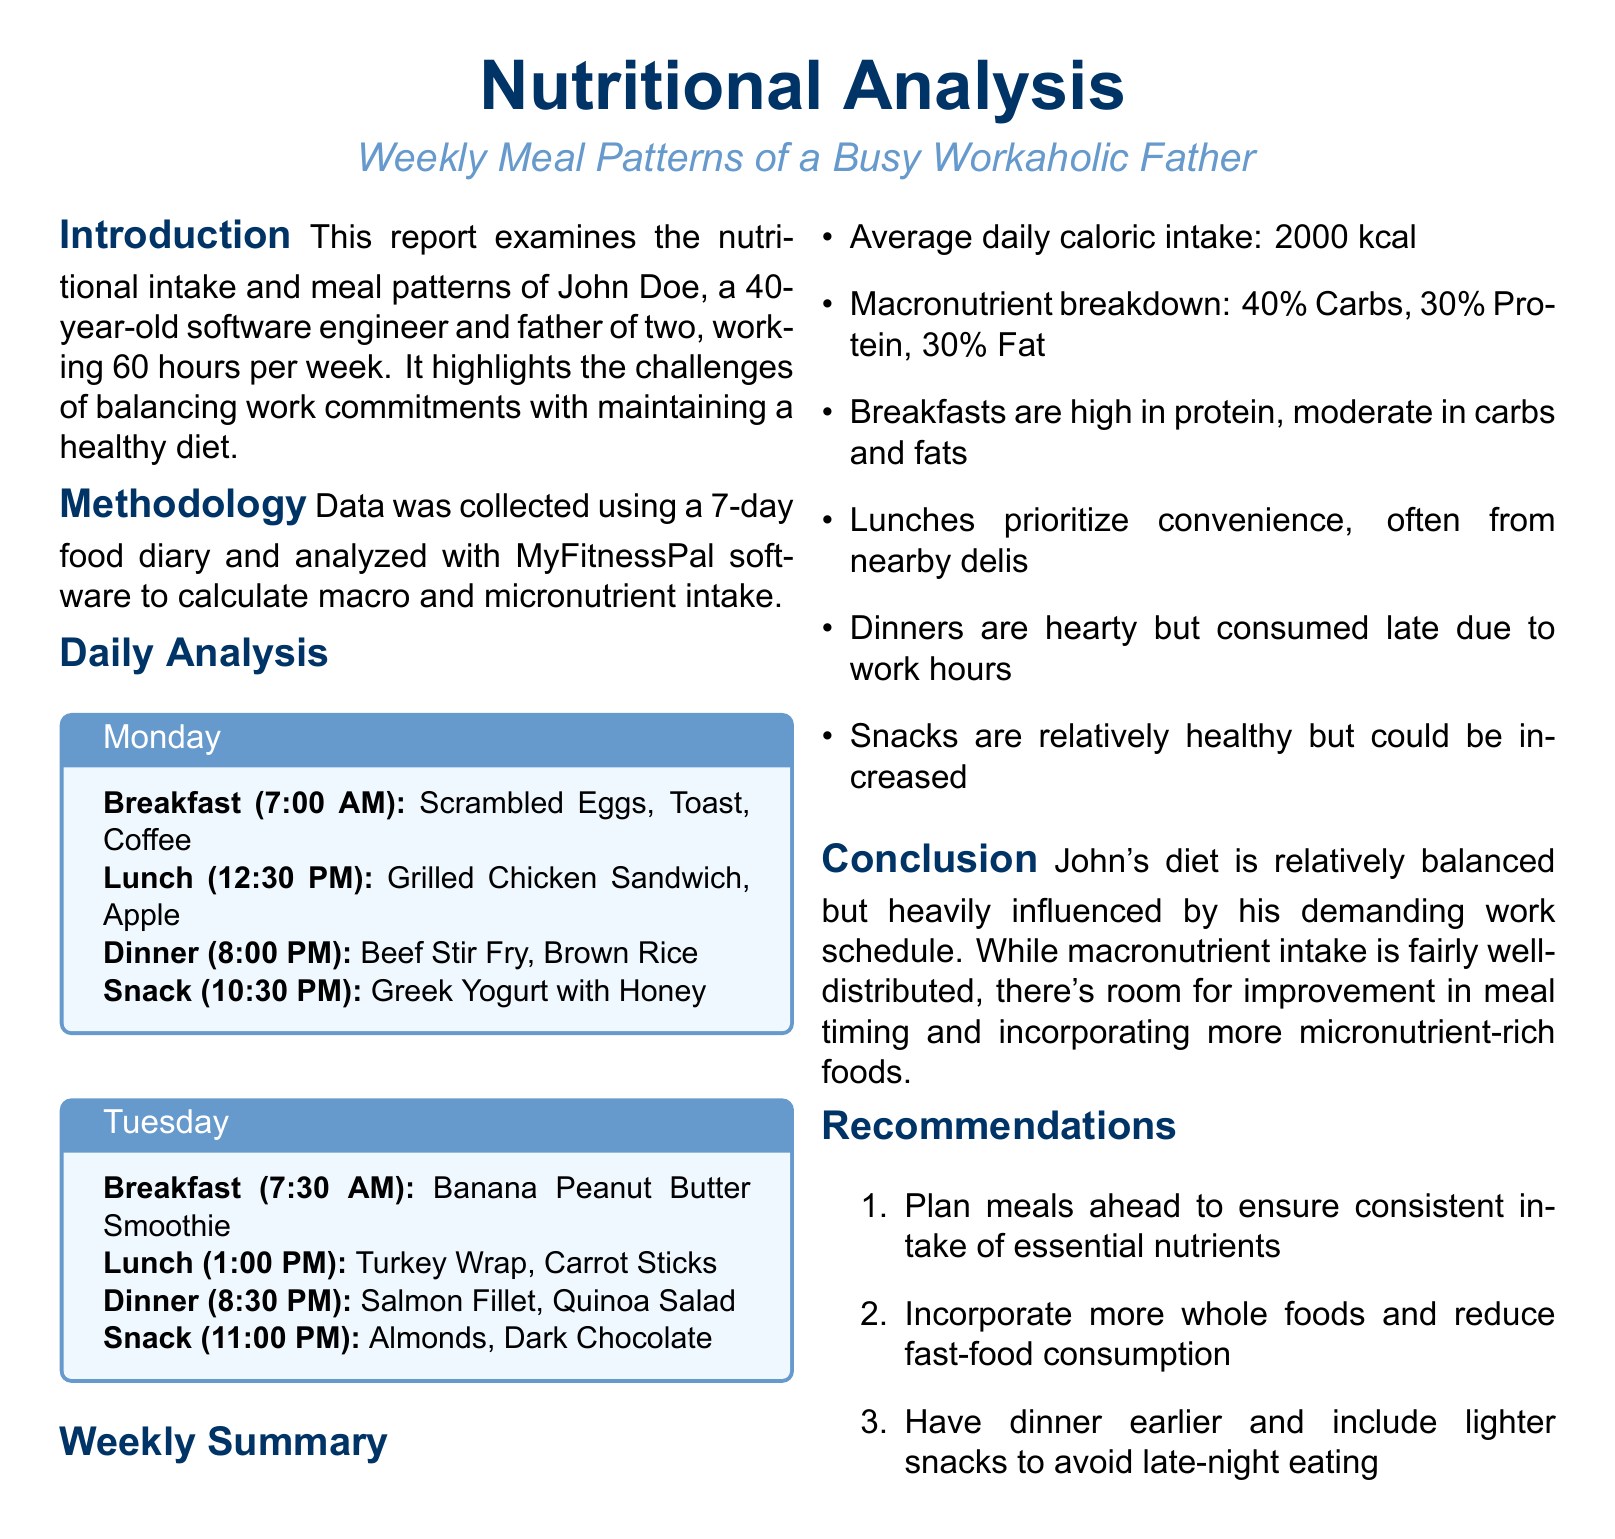What is the average daily caloric intake? The average daily caloric intake is calculated based on the meals consumed over the week, which is 2000 kcal.
Answer: 2000 kcal What is the macronutrient breakdown? The macronutrient breakdown shows the percentage distribution of different nutrients in the diet, which is 40% Carbs, 30% Protein, 30% Fat.
Answer: 40% Carbs, 30% Protein, 30% Fat What time is breakfast typically eaten? Breakfast time is stated for each day, with Monday at 7:00 AM and Tuesday at 7:30 AM indicating it is consumed in the morning.
Answer: 7:00 AM What kind of meals are prioritized for lunch? Lunch meals tend to focus on convenience due to the busy schedule, often sourced from nearby delis.
Answer: Convenience What is a major recommendation for meal planning? The recommendations suggest planning meals ahead to ensure consistent nutrient intake.
Answer: Plan meals ahead What is the primary source of protein in breakfasts? Breakfasts are indicated to be high in protein, particularly from foods like scrambled eggs and smoothies.
Answer: Scrambled Eggs What is the time range for dinners? The dinners are consistently listed as being eaten late, usually between 8:00 PM and 8:30 PM.
Answer: 8:00 PM to 8:30 PM What is one suggestion to improve eating habits? One of the recommendations includes having dinner earlier to promote healthier eating habits.
Answer: Have dinner earlier What was the duration of the data collection? The data collection method utilized a food diary maintained over a week, capturing meals for 7 days.
Answer: 7 days 